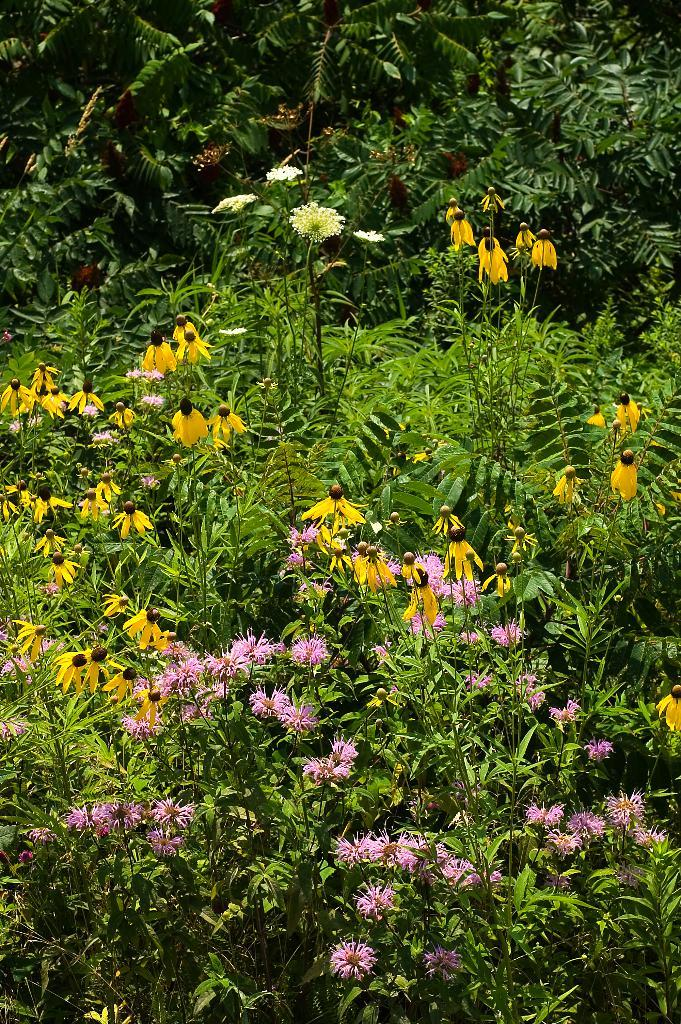What type of plants can be seen in the image? There are flower plants in the image. How would you describe the appearance of the flower plants? The flower plants are beautiful. What time of day is it in the image? The provided facts do not mention the time of day, so it cannot be determined from the image. 